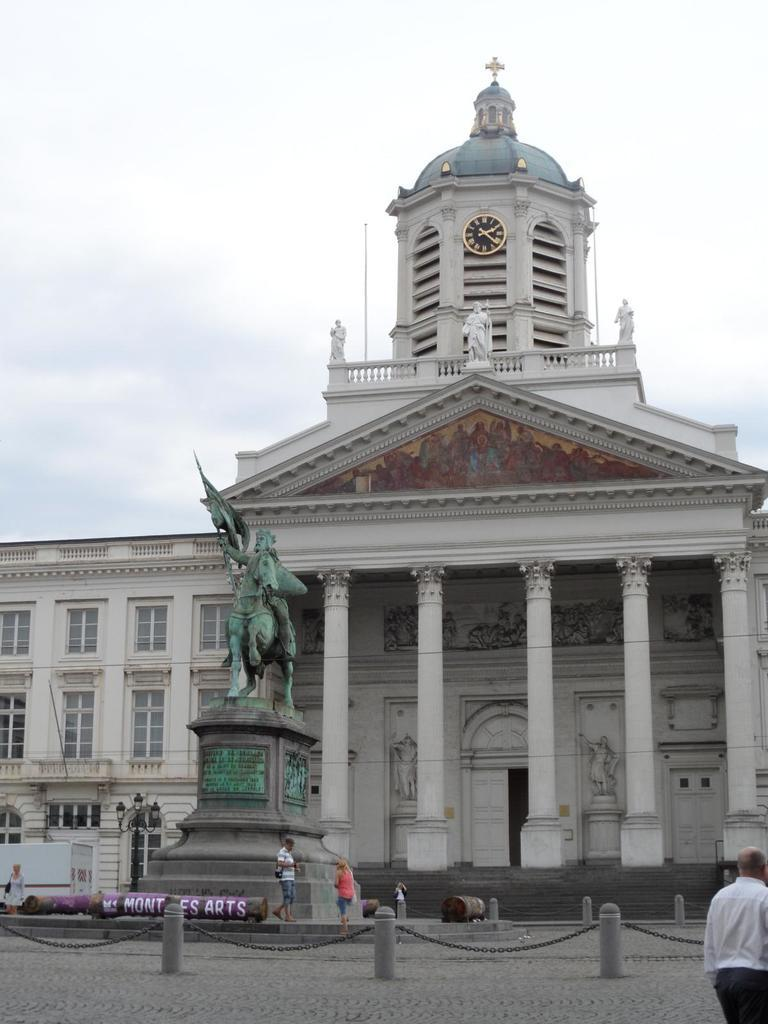What type of structure can be seen in the image? There is a building in the image. What time-telling device is present in the image? There is a clock in the image. What type of decorative figures are in the image? There are statues in the image. What type of street light is visible in the image? There is a light pole in the image. What mode of transportation is present in the image? There is a vehicle in the image. What architectural feature can be seen in the image? There are windows in the image. What type of support structure is present in the image? There are pillars in the image. What type of commemorative marker is present in the image? There is a memorial stone in the image. Are there any human figures in the image? Yes, there are people in the image. What type of entrance is present in the image? There is a door in the image. What type of restraining device is present in the image? There are chains in the image. What is the weather condition in the image? The sky is cloudy in the image. Where is the cub playing in the image? There is no cub present in the image. What type of bed can be seen in the image? There is no bed present in the image. 